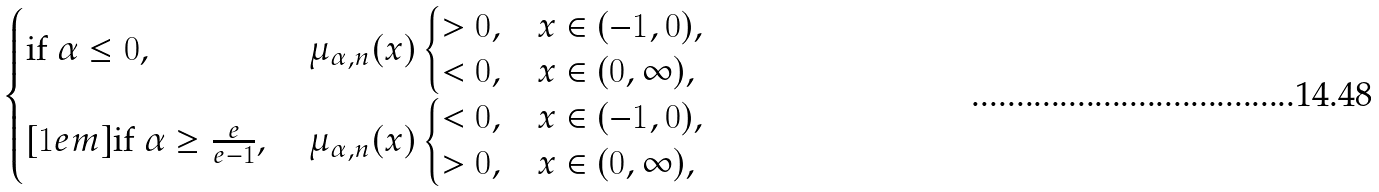<formula> <loc_0><loc_0><loc_500><loc_500>\begin{cases} \text {if $\alpha\leq0$, } & \mu _ { \alpha , n } ( x ) \begin{cases} > 0 , & x \in ( - 1 , 0 ) , \\ < 0 , & x \in ( 0 , \infty ) , \end{cases} \\ [ 1 e m ] \text {if $\alpha\geq\frac{e}{e-1}$, } & \mu _ { \alpha , n } ( x ) \begin{cases} < 0 , & x \in ( - 1 , 0 ) , \\ > 0 , & x \in ( 0 , \infty ) , \end{cases} \end{cases}</formula> 